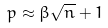Convert formula to latex. <formula><loc_0><loc_0><loc_500><loc_500>p \approx \beta \sqrt { n } + 1</formula> 